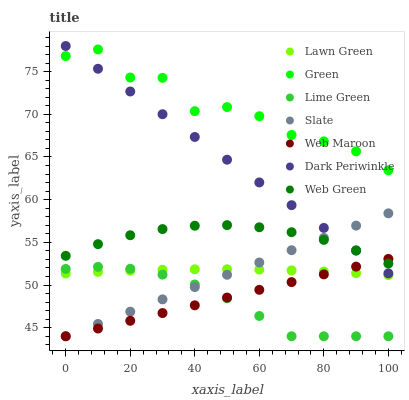Does Lime Green have the minimum area under the curve?
Answer yes or no. Yes. Does Green have the maximum area under the curve?
Answer yes or no. Yes. Does Slate have the minimum area under the curve?
Answer yes or no. No. Does Slate have the maximum area under the curve?
Answer yes or no. No. Is Slate the smoothest?
Answer yes or no. Yes. Is Green the roughest?
Answer yes or no. Yes. Is Web Maroon the smoothest?
Answer yes or no. No. Is Web Maroon the roughest?
Answer yes or no. No. Does Slate have the lowest value?
Answer yes or no. Yes. Does Web Green have the lowest value?
Answer yes or no. No. Does Dark Periwinkle have the highest value?
Answer yes or no. Yes. Does Slate have the highest value?
Answer yes or no. No. Is Lime Green less than Web Green?
Answer yes or no. Yes. Is Web Green greater than Lawn Green?
Answer yes or no. Yes. Does Slate intersect Lime Green?
Answer yes or no. Yes. Is Slate less than Lime Green?
Answer yes or no. No. Is Slate greater than Lime Green?
Answer yes or no. No. Does Lime Green intersect Web Green?
Answer yes or no. No. 